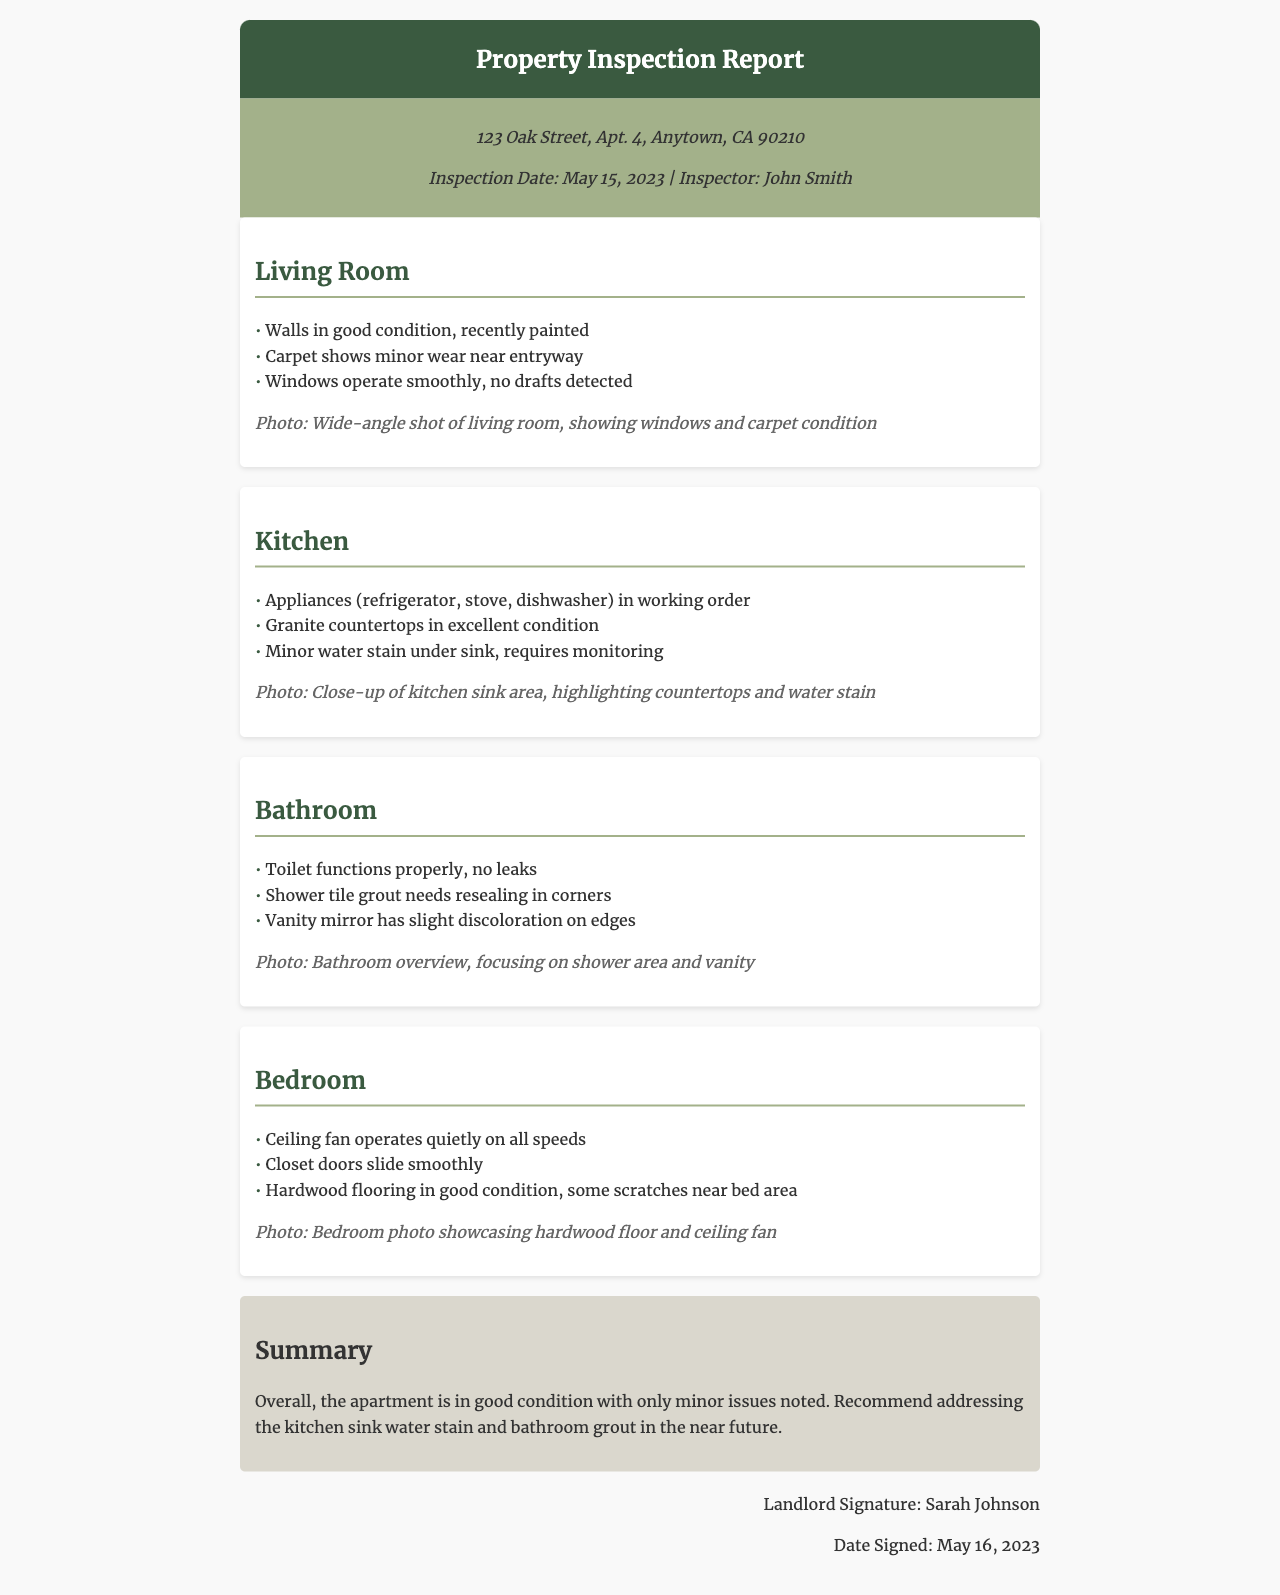What is the inspection date? The inspection date is clearly stated in the document, which is May 15, 2023.
Answer: May 15, 2023 Who is the inspector? The document mentions the inspector's name as John Smith.
Answer: John Smith What condition is the living room carpet in? The document describes the carpet as showing minor wear near the entryway.
Answer: Minor wear Are the kitchen appliances in working order? According to the document, the appliances (refrigerator, stove, dishwasher) are in working order.
Answer: Yes What is recommended to address in the summary? The summary suggests addressing the kitchen sink water stain and bathroom grout.
Answer: Kitchen sink water stain and bathroom grout What color is the header background? The header background color is noted in the document as #3a5a40, which is a shade of green.
Answer: Green How many sections are included in the report? The report contains sections for the living room, kitchen, bathroom, and bedroom, totaling four sections.
Answer: Four What is noted about the bathroom toilet? The document states that the toilet functions properly, with no leaks detected.
Answer: No leaks What observation is made about the bedroom flooring? The observations indicate that the hardwood flooring is in good condition but has some scratches near the bed area.
Answer: Some scratches 